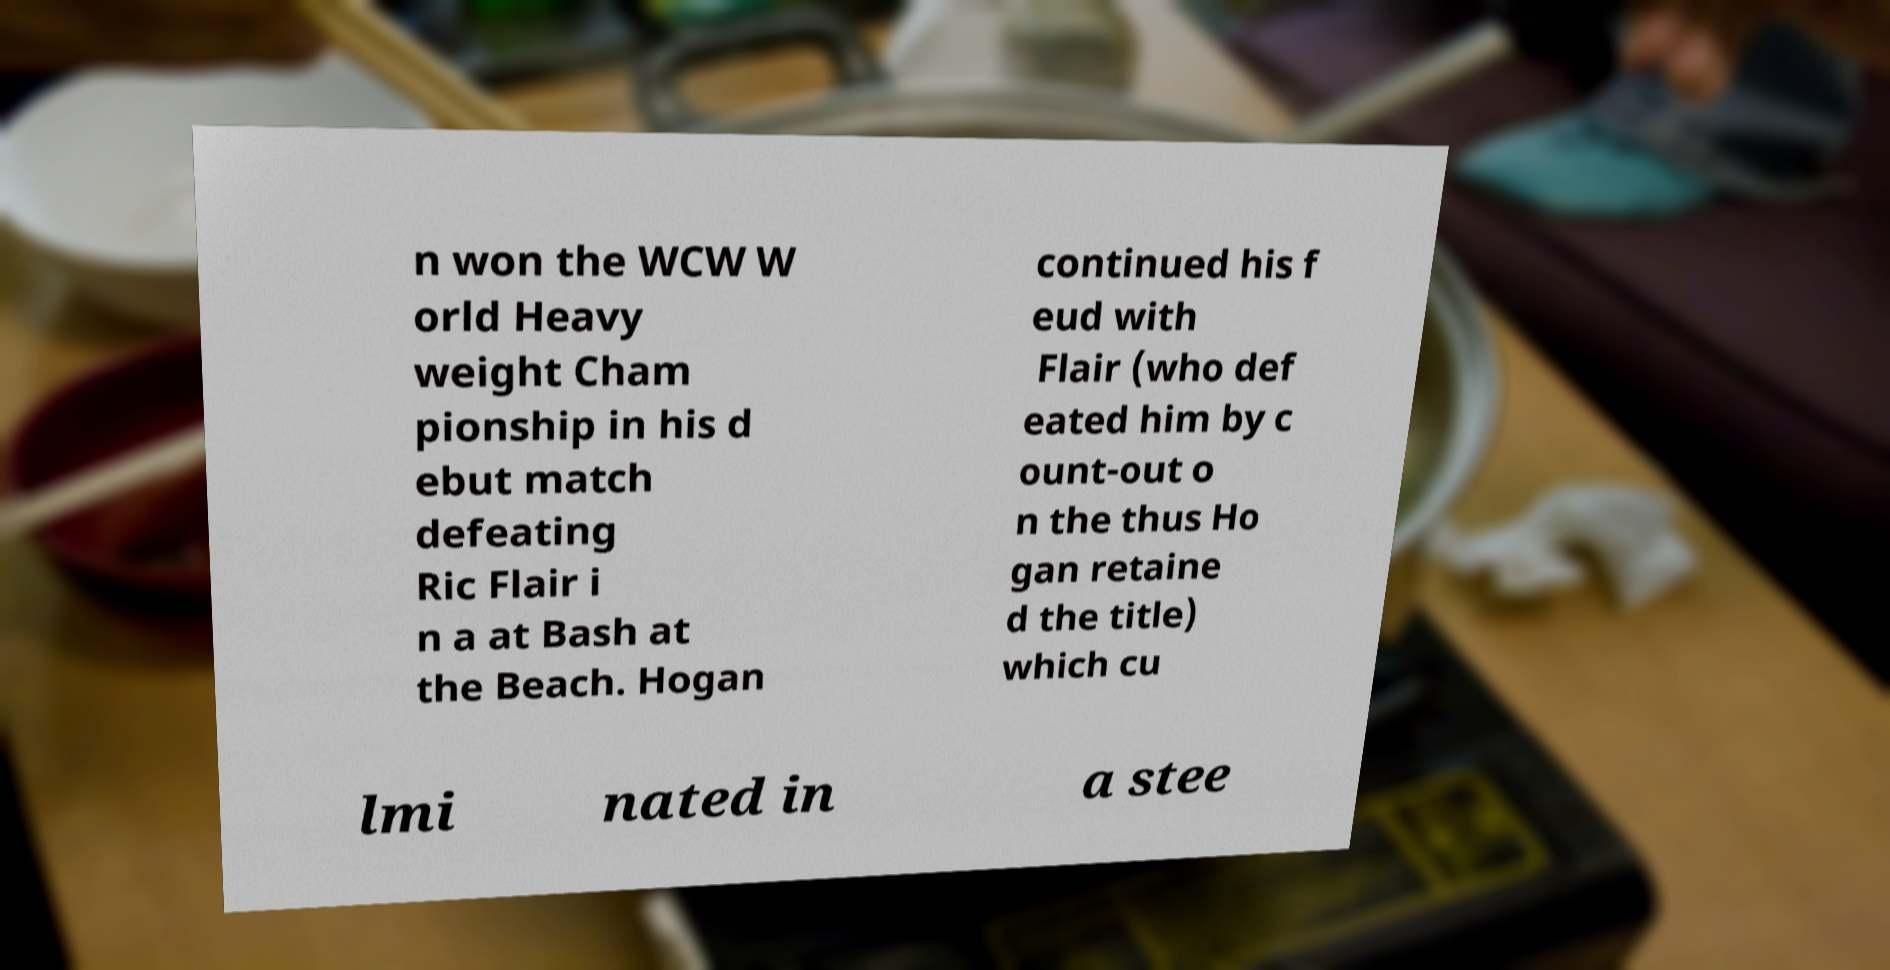Can you read and provide the text displayed in the image?This photo seems to have some interesting text. Can you extract and type it out for me? n won the WCW W orld Heavy weight Cham pionship in his d ebut match defeating Ric Flair i n a at Bash at the Beach. Hogan continued his f eud with Flair (who def eated him by c ount-out o n the thus Ho gan retaine d the title) which cu lmi nated in a stee 